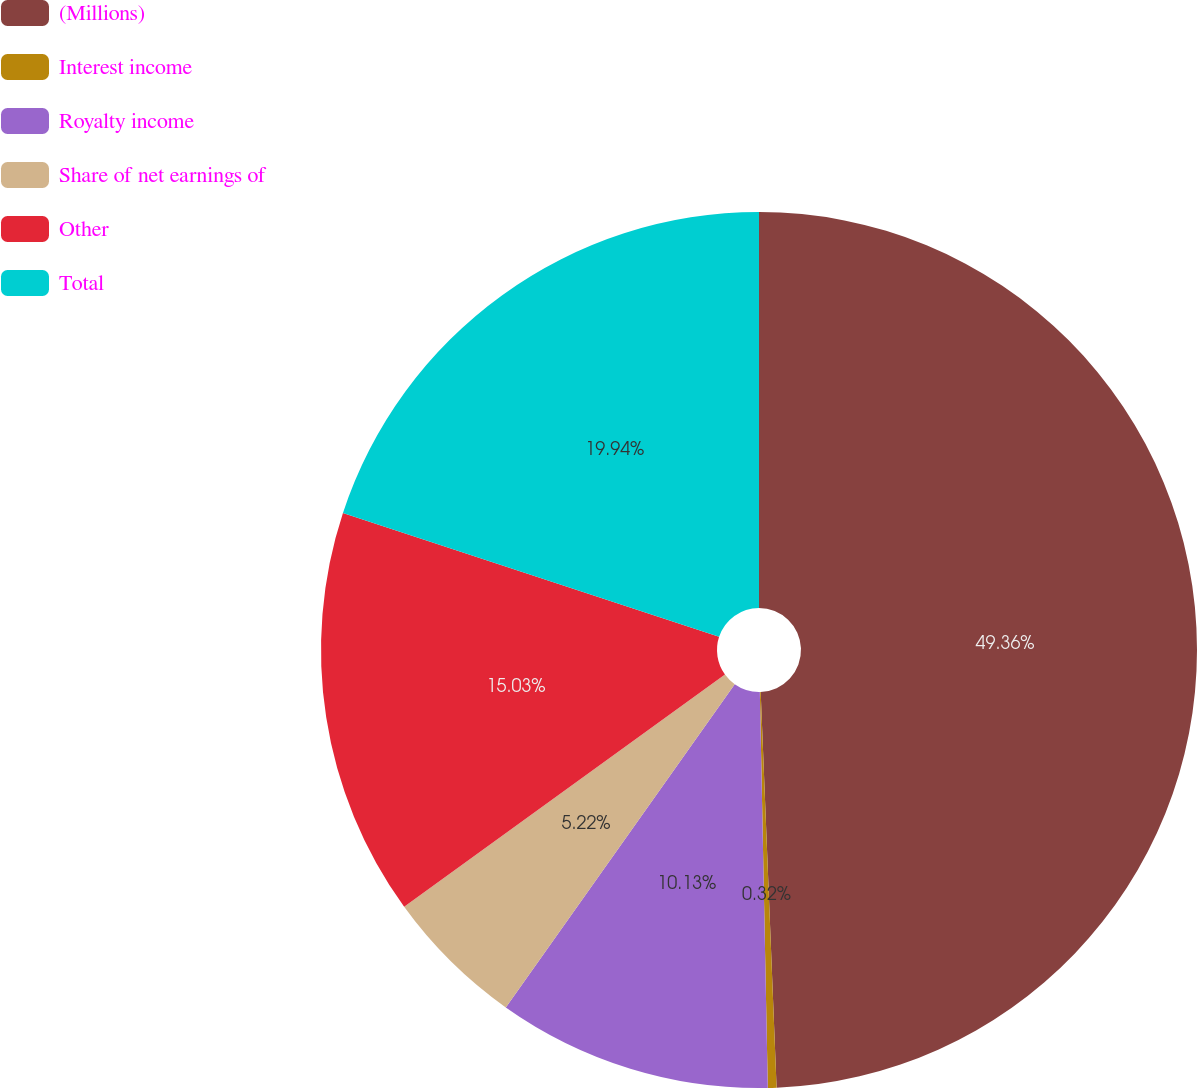Convert chart to OTSL. <chart><loc_0><loc_0><loc_500><loc_500><pie_chart><fcel>(Millions)<fcel>Interest income<fcel>Royalty income<fcel>Share of net earnings of<fcel>Other<fcel>Total<nl><fcel>49.36%<fcel>0.32%<fcel>10.13%<fcel>5.22%<fcel>15.03%<fcel>19.94%<nl></chart> 